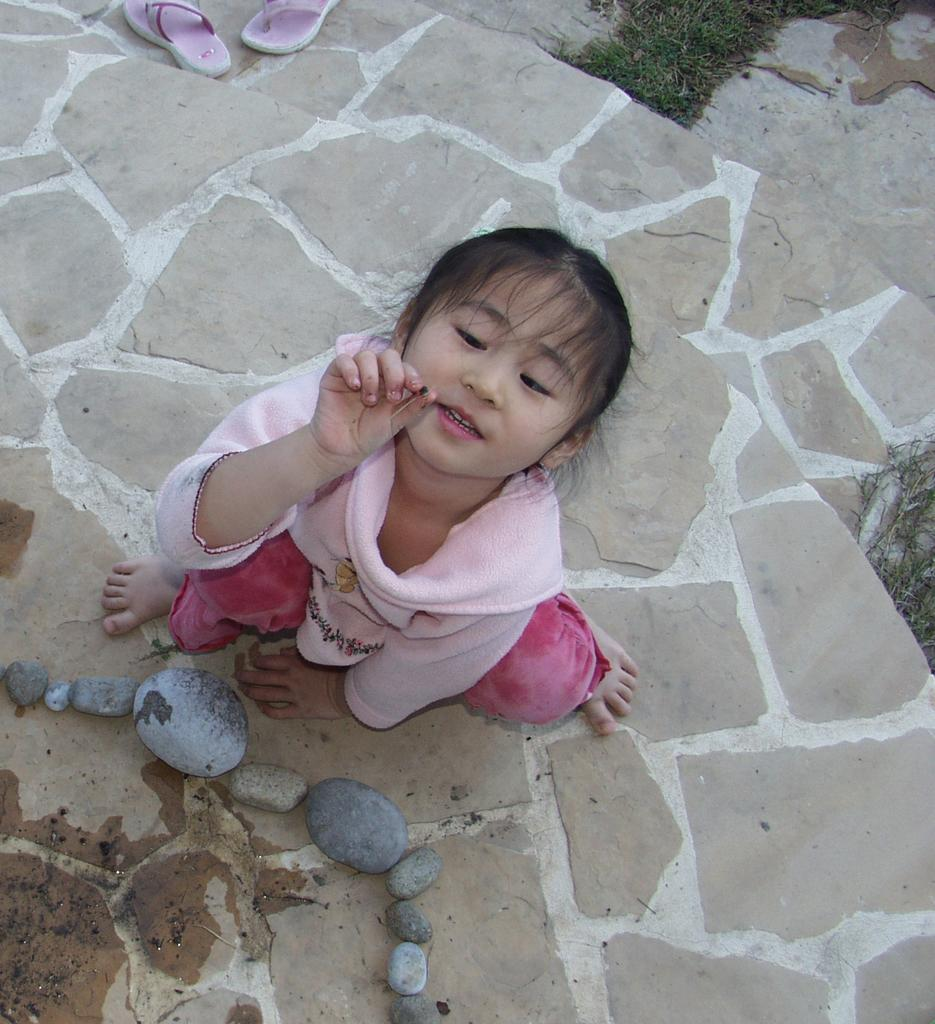Who is the main subject in the image? There is a girl in the image. What is the girl holding in the image? The girl is holding an object. What type of natural elements can be seen in the image? There are stones and grass in the image. Are there any architectural features in the image? Yes, there are stairs in the image. What type of footwear is visible in the image? There is a pair of sandals in the image. What type of butter is being used to paint the rocks in the image? There is no butter or painting activity present in the image. 